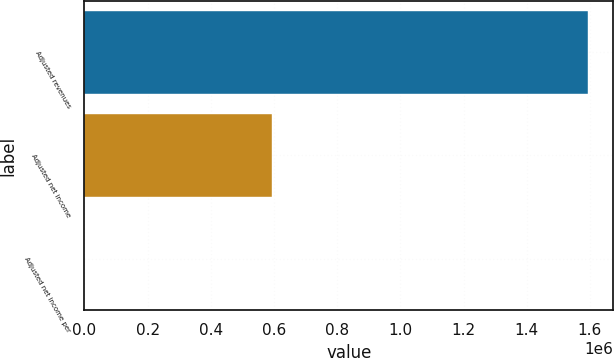<chart> <loc_0><loc_0><loc_500><loc_500><bar_chart><fcel>Adjusted revenues<fcel>Adjusted net income<fcel>Adjusted net income per<nl><fcel>1.59461e+06<fcel>592625<fcel>6.3<nl></chart> 